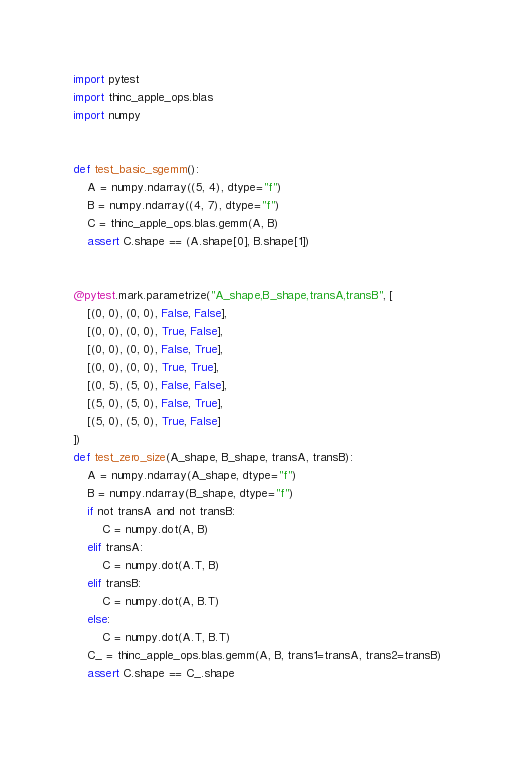Convert code to text. <code><loc_0><loc_0><loc_500><loc_500><_Python_>import pytest
import thinc_apple_ops.blas
import numpy


def test_basic_sgemm():
    A = numpy.ndarray((5, 4), dtype="f")
    B = numpy.ndarray((4, 7), dtype="f")
    C = thinc_apple_ops.blas.gemm(A, B)
    assert C.shape == (A.shape[0], B.shape[1])


@pytest.mark.parametrize("A_shape,B_shape,transA,transB", [
    [(0, 0), (0, 0), False, False],
    [(0, 0), (0, 0), True, False],
    [(0, 0), (0, 0), False, True],
    [(0, 0), (0, 0), True, True],
    [(0, 5), (5, 0), False, False],
    [(5, 0), (5, 0), False, True],
    [(5, 0), (5, 0), True, False]
])
def test_zero_size(A_shape, B_shape, transA, transB):
    A = numpy.ndarray(A_shape, dtype="f")
    B = numpy.ndarray(B_shape, dtype="f")
    if not transA and not transB:
        C = numpy.dot(A, B)
    elif transA:
        C = numpy.dot(A.T, B)
    elif transB:
        C = numpy.dot(A, B.T)
    else:
        C = numpy.dot(A.T, B.T)
    C_ = thinc_apple_ops.blas.gemm(A, B, trans1=transA, trans2=transB)
    assert C.shape == C_.shape


</code> 